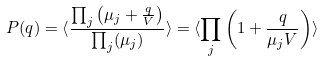<formula> <loc_0><loc_0><loc_500><loc_500>P ( q ) = \langle \frac { \prod _ { j } \left ( \mu _ { j } + \frac { q } { V } \right ) } { \prod _ { j } ( \mu _ { j } ) } \rangle = \langle \prod _ { j } \left ( 1 + \frac { q } { \mu _ { j } V } \right ) \rangle</formula> 